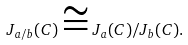Convert formula to latex. <formula><loc_0><loc_0><loc_500><loc_500>J _ { a / b } ( C ) \cong J _ { a } ( C ) / J _ { b } ( C ) .</formula> 